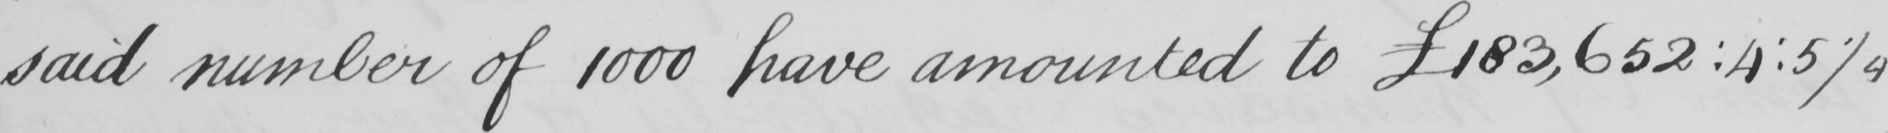Can you tell me what this handwritten text says? said number of 1000 have amounted to  £183,652 : 4 : 5 1/4 